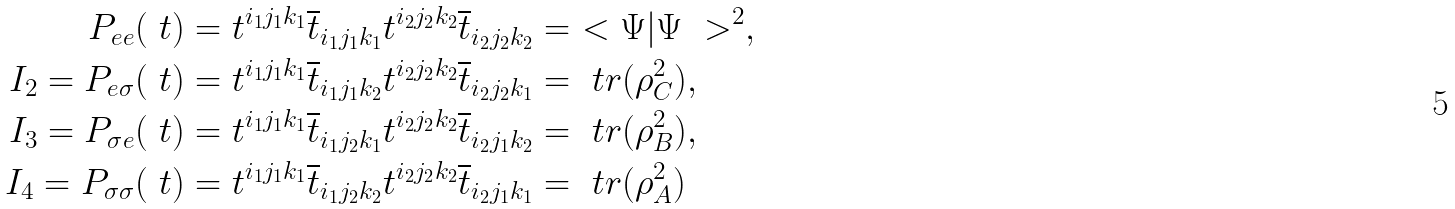Convert formula to latex. <formula><loc_0><loc_0><loc_500><loc_500>P _ { e e } ( \ t ) & = t ^ { i _ { 1 } j _ { 1 } k _ { 1 } } \overline { t } _ { i _ { 1 } j _ { 1 } k _ { 1 } } t ^ { i _ { 2 } j _ { 2 } k _ { 2 } } \overline { t } _ { i _ { 2 } j _ { 2 } k _ { 2 } } = \ < \Psi | \Psi \ > ^ { 2 } , \\ I _ { 2 } = P _ { e \sigma } ( \ t ) & = t ^ { i _ { 1 } j _ { 1 } k _ { 1 } } \overline { t } _ { i _ { 1 } j _ { 1 } k _ { 2 } } t ^ { i _ { 2 } j _ { 2 } k _ { 2 } } \overline { t } _ { i _ { 2 } j _ { 2 } k _ { 1 } } = \ t r ( \rho _ { C } ^ { 2 } ) , \\ I _ { 3 } = P _ { \sigma e } ( \ t ) & = t ^ { i _ { 1 } j _ { 1 } k _ { 1 } } \overline { t } _ { i _ { 1 } j _ { 2 } k _ { 1 } } t ^ { i _ { 2 } j _ { 2 } k _ { 2 } } \overline { t } _ { i _ { 2 } j _ { 1 } k _ { 2 } } = \ t r ( \rho _ { B } ^ { 2 } ) , \\ I _ { 4 } = P _ { \sigma \sigma } ( \ t ) & = t ^ { i _ { 1 } j _ { 1 } k _ { 1 } } \overline { t } _ { i _ { 1 } j _ { 2 } k _ { 2 } } t ^ { i _ { 2 } j _ { 2 } k _ { 2 } } \overline { t } _ { i _ { 2 } j _ { 1 } k _ { 1 } } = \ t r ( \rho _ { A } ^ { 2 } )</formula> 